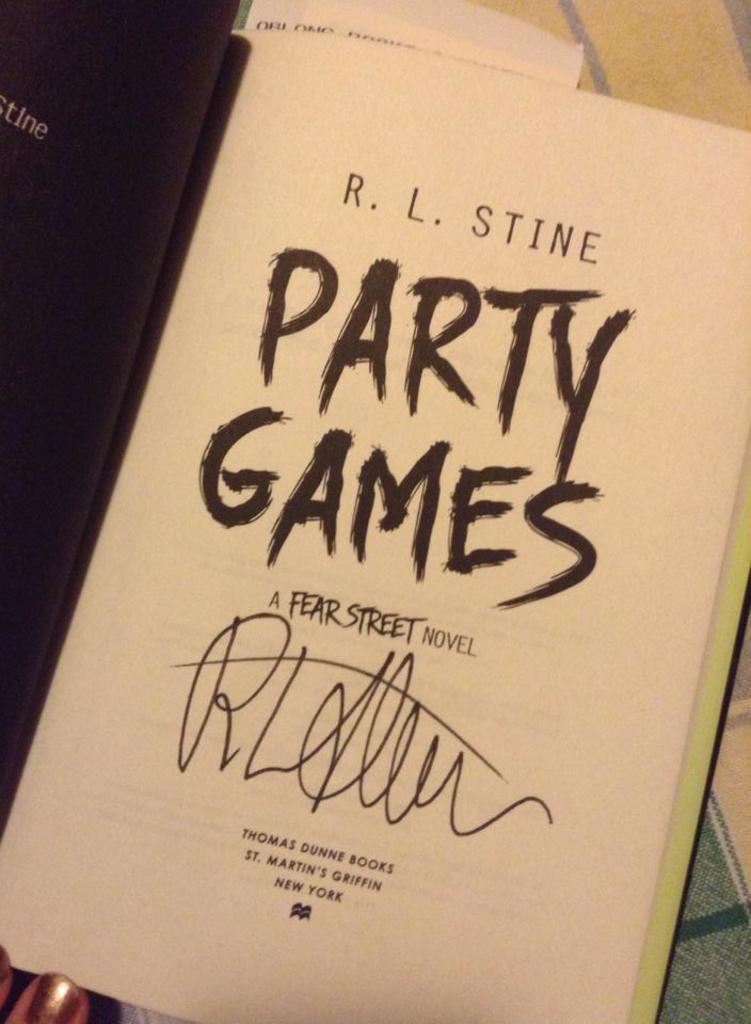<image>
Share a concise interpretation of the image provided. A page in the book Party Games by R.L. Stine. 